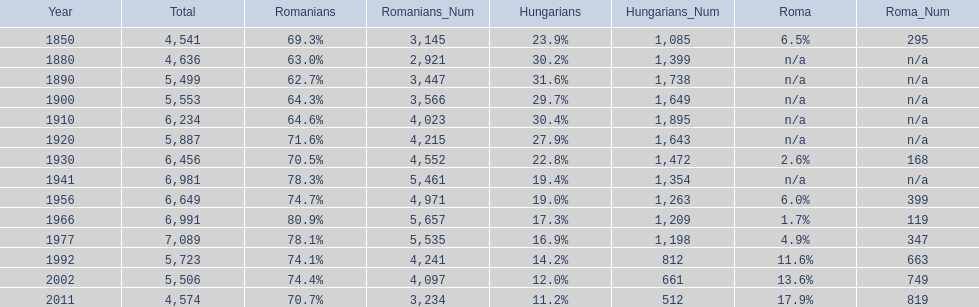What percent of the population were romanians according to the last year on this chart? 70.7%. 